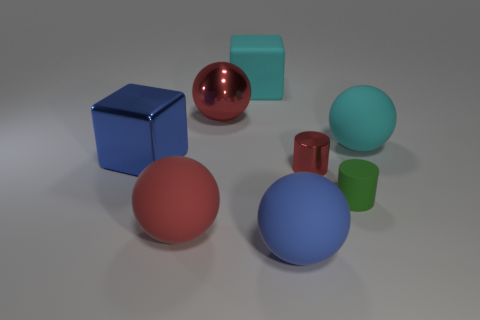How would you describe the overall composition and the interplay of colors in this image? The composition is a balanced arrangement of geometric shapes, featuring a harmonious mix of colors. The vivid red, blue, and green elements stand out against the more neutral backgrounds, creating an image that's aesthetically pleasing and engaging to the eye. 